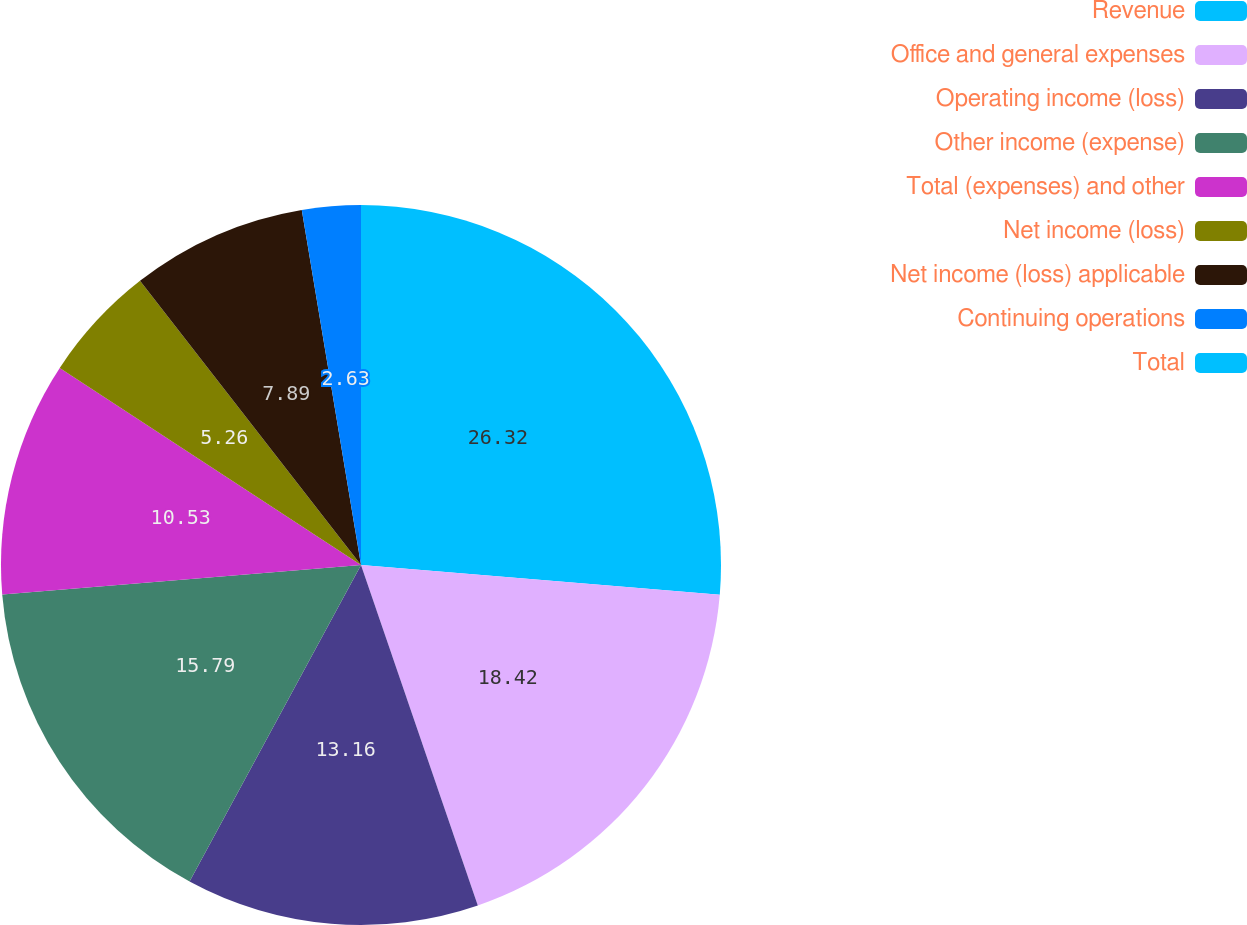Convert chart. <chart><loc_0><loc_0><loc_500><loc_500><pie_chart><fcel>Revenue<fcel>Office and general expenses<fcel>Operating income (loss)<fcel>Other income (expense)<fcel>Total (expenses) and other<fcel>Net income (loss)<fcel>Net income (loss) applicable<fcel>Continuing operations<fcel>Total<nl><fcel>26.32%<fcel>18.42%<fcel>13.16%<fcel>15.79%<fcel>10.53%<fcel>5.26%<fcel>7.89%<fcel>2.63%<fcel>0.0%<nl></chart> 